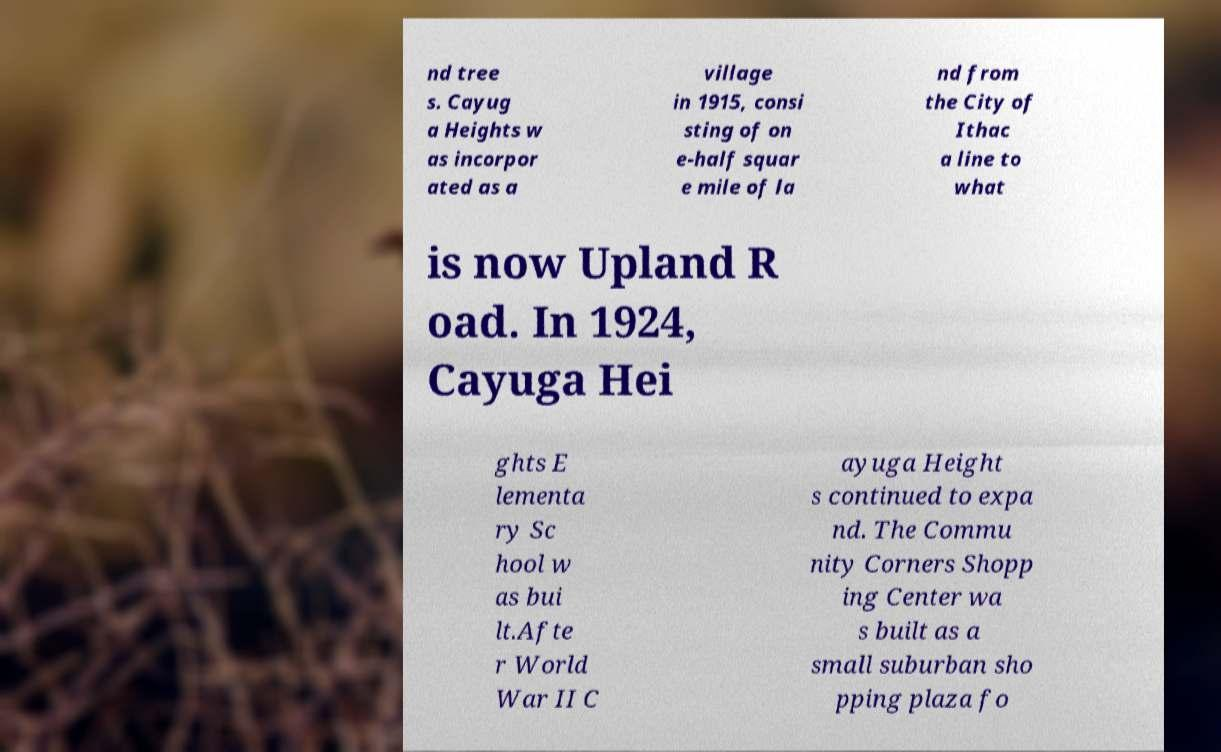Can you accurately transcribe the text from the provided image for me? nd tree s. Cayug a Heights w as incorpor ated as a village in 1915, consi sting of on e-half squar e mile of la nd from the City of Ithac a line to what is now Upland R oad. In 1924, Cayuga Hei ghts E lementa ry Sc hool w as bui lt.Afte r World War II C ayuga Height s continued to expa nd. The Commu nity Corners Shopp ing Center wa s built as a small suburban sho pping plaza fo 